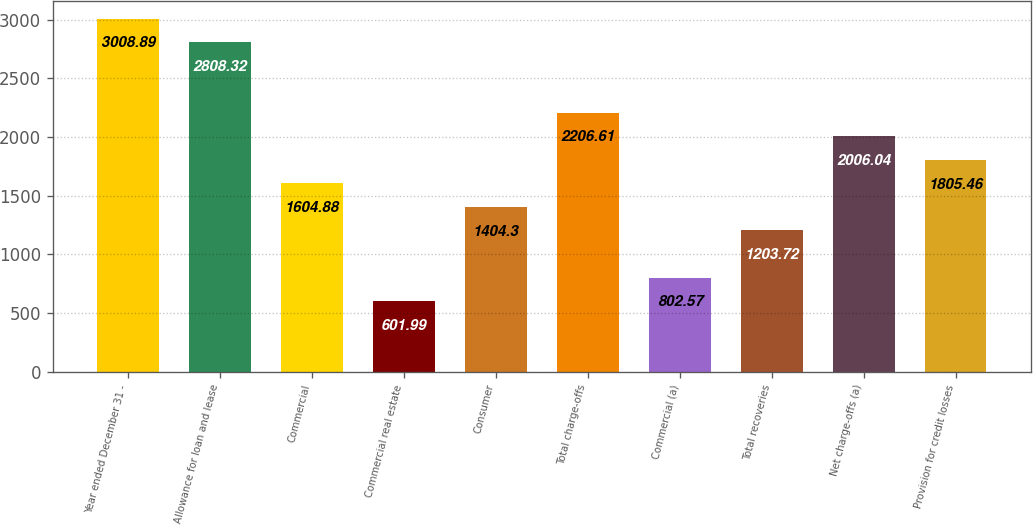<chart> <loc_0><loc_0><loc_500><loc_500><bar_chart><fcel>Year ended December 31 -<fcel>Allowance for loan and lease<fcel>Commercial<fcel>Commercial real estate<fcel>Consumer<fcel>Total charge-offs<fcel>Commercial (a)<fcel>Total recoveries<fcel>Net charge-offs (a)<fcel>Provision for credit losses<nl><fcel>3008.89<fcel>2808.32<fcel>1604.88<fcel>601.99<fcel>1404.3<fcel>2206.61<fcel>802.57<fcel>1203.72<fcel>2006.04<fcel>1805.46<nl></chart> 